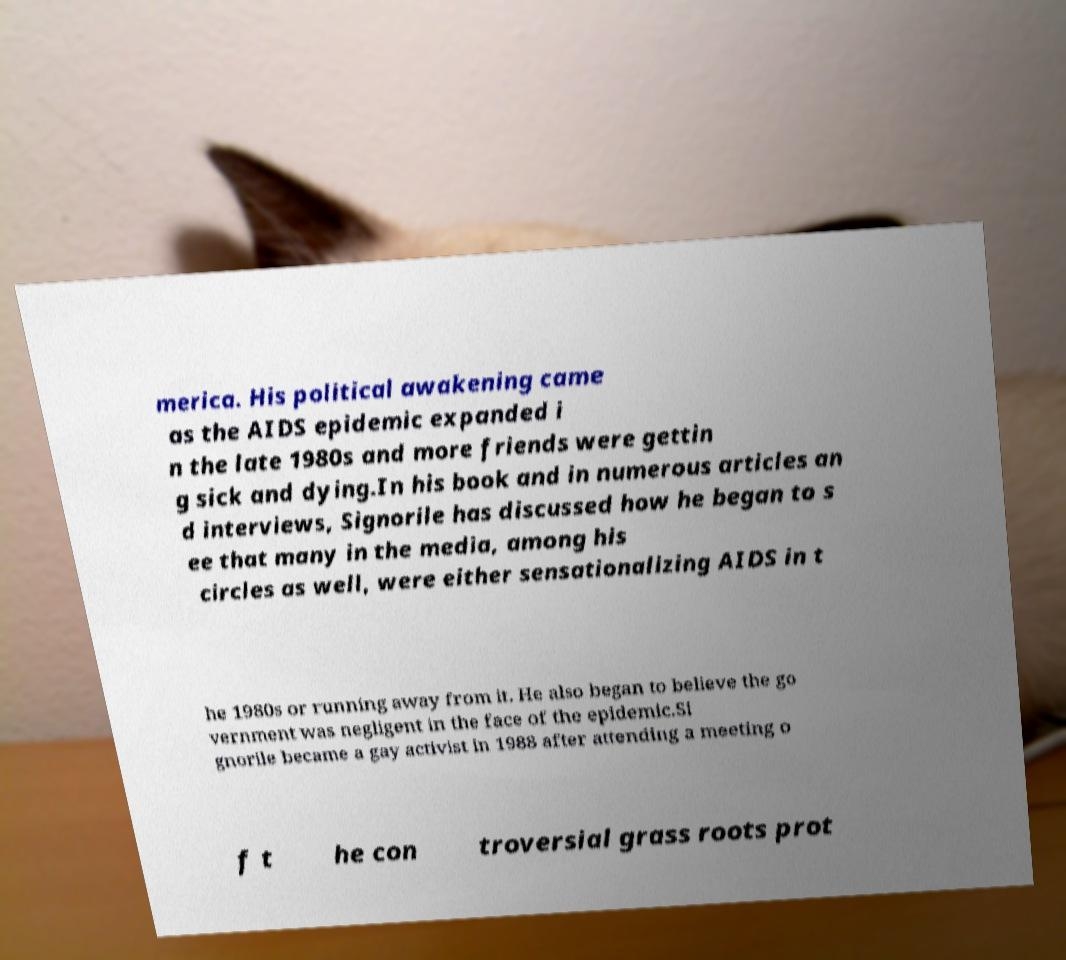Could you extract and type out the text from this image? merica. His political awakening came as the AIDS epidemic expanded i n the late 1980s and more friends were gettin g sick and dying.In his book and in numerous articles an d interviews, Signorile has discussed how he began to s ee that many in the media, among his circles as well, were either sensationalizing AIDS in t he 1980s or running away from it. He also began to believe the go vernment was negligent in the face of the epidemic.Si gnorile became a gay activist in 1988 after attending a meeting o f t he con troversial grass roots prot 